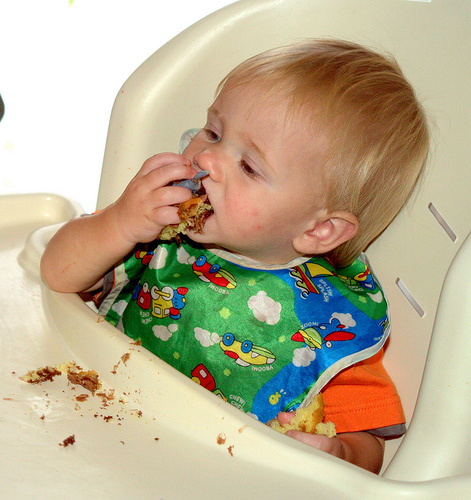<image>
Is there a bib in the tray? No. The bib is not contained within the tray. These objects have a different spatial relationship. 